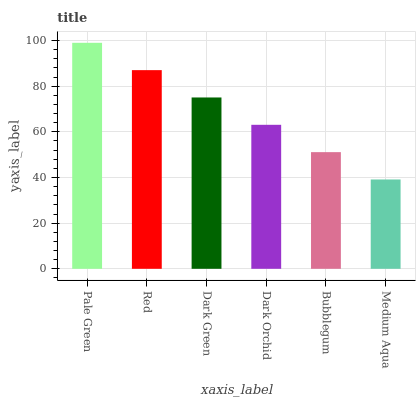Is Medium Aqua the minimum?
Answer yes or no. Yes. Is Pale Green the maximum?
Answer yes or no. Yes. Is Red the minimum?
Answer yes or no. No. Is Red the maximum?
Answer yes or no. No. Is Pale Green greater than Red?
Answer yes or no. Yes. Is Red less than Pale Green?
Answer yes or no. Yes. Is Red greater than Pale Green?
Answer yes or no. No. Is Pale Green less than Red?
Answer yes or no. No. Is Dark Green the high median?
Answer yes or no. Yes. Is Dark Orchid the low median?
Answer yes or no. Yes. Is Dark Orchid the high median?
Answer yes or no. No. Is Pale Green the low median?
Answer yes or no. No. 